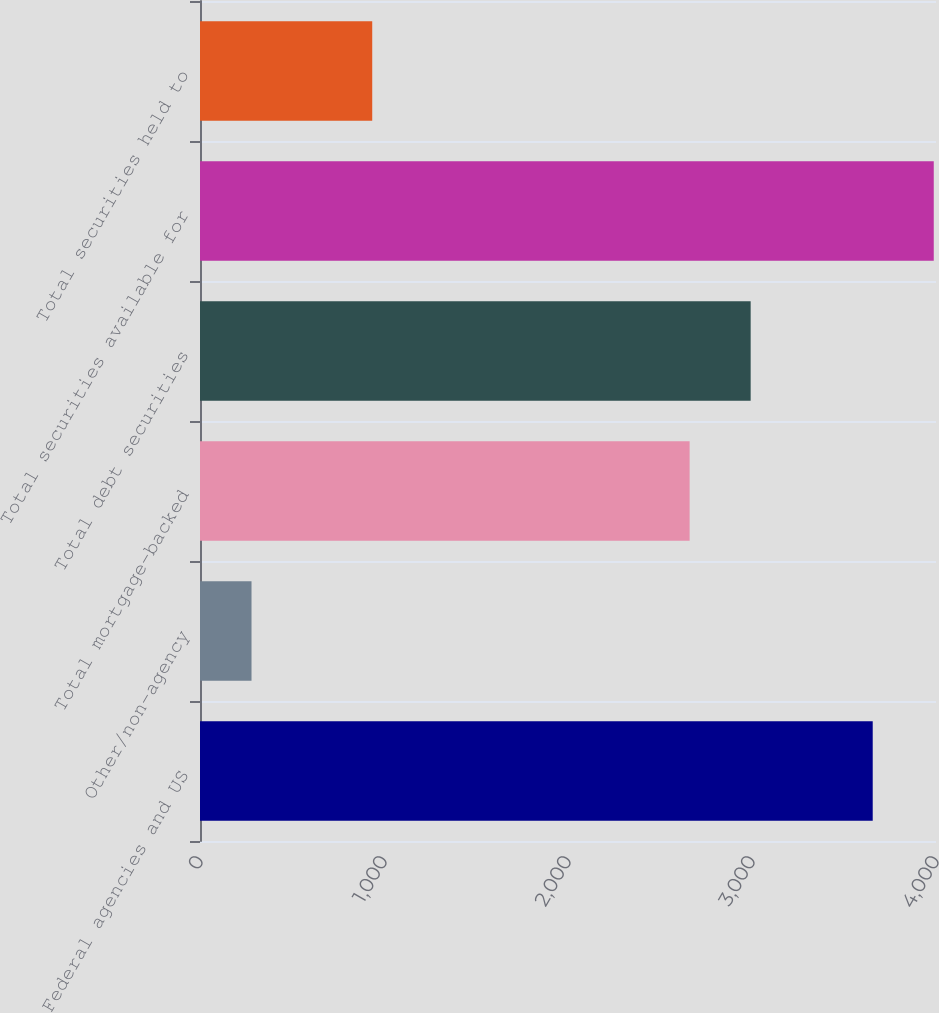Convert chart to OTSL. <chart><loc_0><loc_0><loc_500><loc_500><bar_chart><fcel>Federal agencies and US<fcel>Other/non-agency<fcel>Total mortgage-backed<fcel>Total debt securities<fcel>Total securities available for<fcel>Total securities held to<nl><fcel>3656.1<fcel>280<fcel>2661<fcel>2992.7<fcel>3987.8<fcel>936<nl></chart> 